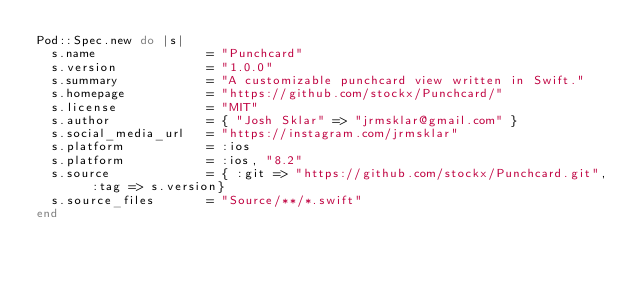Convert code to text. <code><loc_0><loc_0><loc_500><loc_500><_Ruby_>Pod::Spec.new do |s|
  s.name               = "Punchcard"
  s.version            = "1.0.0"
  s.summary            = "A customizable punchcard view written in Swift."
  s.homepage           = "https://github.com/stockx/Punchcard/"
  s.license            = "MIT"
  s.author             = { "Josh Sklar" => "jrmsklar@gmail.com" }
  s.social_media_url   = "https://instagram.com/jrmsklar"
  s.platform           = :ios
  s.platform           = :ios, "8.2"
  s.source             = { :git => "https://github.com/stockx/Punchcard.git", :tag => s.version}
  s.source_files       = "Source/**/*.swift"
end
</code> 